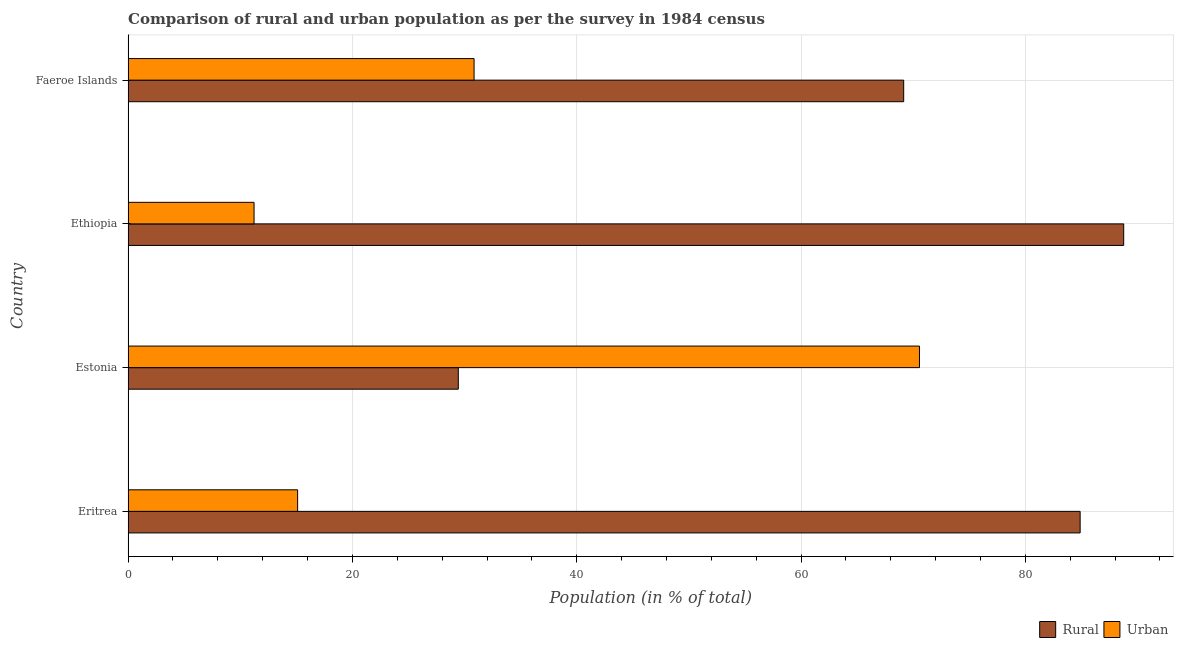How many groups of bars are there?
Your answer should be compact. 4. Are the number of bars per tick equal to the number of legend labels?
Your answer should be compact. Yes. Are the number of bars on each tick of the Y-axis equal?
Provide a short and direct response. Yes. How many bars are there on the 2nd tick from the top?
Your response must be concise. 2. What is the label of the 1st group of bars from the top?
Provide a succinct answer. Faeroe Islands. What is the urban population in Ethiopia?
Keep it short and to the point. 11.23. Across all countries, what is the maximum rural population?
Make the answer very short. 88.77. Across all countries, what is the minimum rural population?
Your answer should be very brief. 29.44. In which country was the rural population maximum?
Make the answer very short. Ethiopia. In which country was the rural population minimum?
Your response must be concise. Estonia. What is the total urban population in the graph?
Your response must be concise. 127.76. What is the difference between the rural population in Estonia and that in Ethiopia?
Provide a succinct answer. -59.33. What is the difference between the rural population in Estonia and the urban population in Ethiopia?
Your response must be concise. 18.21. What is the average rural population per country?
Keep it short and to the point. 68.06. What is the difference between the rural population and urban population in Ethiopia?
Provide a succinct answer. 77.54. In how many countries, is the rural population greater than 88 %?
Keep it short and to the point. 1. What is the ratio of the urban population in Estonia to that in Ethiopia?
Ensure brevity in your answer.  6.28. Is the urban population in Eritrea less than that in Estonia?
Keep it short and to the point. Yes. Is the difference between the rural population in Eritrea and Estonia greater than the difference between the urban population in Eritrea and Estonia?
Keep it short and to the point. Yes. What is the difference between the highest and the second highest urban population?
Offer a terse response. 39.71. What is the difference between the highest and the lowest urban population?
Offer a terse response. 59.33. Is the sum of the urban population in Estonia and Ethiopia greater than the maximum rural population across all countries?
Provide a succinct answer. No. What does the 1st bar from the top in Eritrea represents?
Your answer should be very brief. Urban. What does the 2nd bar from the bottom in Ethiopia represents?
Your answer should be compact. Urban. Are the values on the major ticks of X-axis written in scientific E-notation?
Offer a terse response. No. Does the graph contain any zero values?
Your answer should be very brief. No. Does the graph contain grids?
Your answer should be very brief. Yes. How many legend labels are there?
Offer a very short reply. 2. What is the title of the graph?
Your answer should be compact. Comparison of rural and urban population as per the survey in 1984 census. Does "Urban" appear as one of the legend labels in the graph?
Keep it short and to the point. Yes. What is the label or title of the X-axis?
Your response must be concise. Population (in % of total). What is the Population (in % of total) of Rural in Eritrea?
Your answer should be compact. 84.88. What is the Population (in % of total) in Urban in Eritrea?
Make the answer very short. 15.12. What is the Population (in % of total) in Rural in Estonia?
Offer a very short reply. 29.44. What is the Population (in % of total) of Urban in Estonia?
Your answer should be compact. 70.56. What is the Population (in % of total) of Rural in Ethiopia?
Ensure brevity in your answer.  88.77. What is the Population (in % of total) in Urban in Ethiopia?
Your answer should be compact. 11.23. What is the Population (in % of total) of Rural in Faeroe Islands?
Provide a succinct answer. 69.15. What is the Population (in % of total) of Urban in Faeroe Islands?
Provide a short and direct response. 30.85. Across all countries, what is the maximum Population (in % of total) of Rural?
Give a very brief answer. 88.77. Across all countries, what is the maximum Population (in % of total) of Urban?
Provide a short and direct response. 70.56. Across all countries, what is the minimum Population (in % of total) in Rural?
Your answer should be compact. 29.44. Across all countries, what is the minimum Population (in % of total) in Urban?
Your answer should be very brief. 11.23. What is the total Population (in % of total) in Rural in the graph?
Give a very brief answer. 272.25. What is the total Population (in % of total) of Urban in the graph?
Your response must be concise. 127.75. What is the difference between the Population (in % of total) in Rural in Eritrea and that in Estonia?
Make the answer very short. 55.44. What is the difference between the Population (in % of total) in Urban in Eritrea and that in Estonia?
Make the answer very short. -55.44. What is the difference between the Population (in % of total) in Rural in Eritrea and that in Ethiopia?
Provide a succinct answer. -3.88. What is the difference between the Population (in % of total) of Urban in Eritrea and that in Ethiopia?
Your response must be concise. 3.88. What is the difference between the Population (in % of total) of Rural in Eritrea and that in Faeroe Islands?
Your answer should be very brief. 15.73. What is the difference between the Population (in % of total) in Urban in Eritrea and that in Faeroe Islands?
Make the answer very short. -15.73. What is the difference between the Population (in % of total) in Rural in Estonia and that in Ethiopia?
Keep it short and to the point. -59.33. What is the difference between the Population (in % of total) of Urban in Estonia and that in Ethiopia?
Give a very brief answer. 59.33. What is the difference between the Population (in % of total) of Rural in Estonia and that in Faeroe Islands?
Offer a very short reply. -39.71. What is the difference between the Population (in % of total) of Urban in Estonia and that in Faeroe Islands?
Offer a very short reply. 39.71. What is the difference between the Population (in % of total) of Rural in Ethiopia and that in Faeroe Islands?
Ensure brevity in your answer.  19.62. What is the difference between the Population (in % of total) in Urban in Ethiopia and that in Faeroe Islands?
Provide a short and direct response. -19.62. What is the difference between the Population (in % of total) in Rural in Eritrea and the Population (in % of total) in Urban in Estonia?
Make the answer very short. 14.33. What is the difference between the Population (in % of total) in Rural in Eritrea and the Population (in % of total) in Urban in Ethiopia?
Your answer should be compact. 73.65. What is the difference between the Population (in % of total) in Rural in Eritrea and the Population (in % of total) in Urban in Faeroe Islands?
Offer a terse response. 54.03. What is the difference between the Population (in % of total) of Rural in Estonia and the Population (in % of total) of Urban in Ethiopia?
Offer a terse response. 18.21. What is the difference between the Population (in % of total) in Rural in Estonia and the Population (in % of total) in Urban in Faeroe Islands?
Offer a very short reply. -1.41. What is the difference between the Population (in % of total) of Rural in Ethiopia and the Population (in % of total) of Urban in Faeroe Islands?
Your answer should be very brief. 57.92. What is the average Population (in % of total) in Rural per country?
Your answer should be compact. 68.06. What is the average Population (in % of total) in Urban per country?
Provide a succinct answer. 31.94. What is the difference between the Population (in % of total) of Rural and Population (in % of total) of Urban in Eritrea?
Provide a short and direct response. 69.77. What is the difference between the Population (in % of total) of Rural and Population (in % of total) of Urban in Estonia?
Offer a terse response. -41.12. What is the difference between the Population (in % of total) of Rural and Population (in % of total) of Urban in Ethiopia?
Your answer should be very brief. 77.54. What is the difference between the Population (in % of total) of Rural and Population (in % of total) of Urban in Faeroe Islands?
Make the answer very short. 38.3. What is the ratio of the Population (in % of total) in Rural in Eritrea to that in Estonia?
Offer a terse response. 2.88. What is the ratio of the Population (in % of total) of Urban in Eritrea to that in Estonia?
Offer a very short reply. 0.21. What is the ratio of the Population (in % of total) of Rural in Eritrea to that in Ethiopia?
Your answer should be very brief. 0.96. What is the ratio of the Population (in % of total) in Urban in Eritrea to that in Ethiopia?
Provide a short and direct response. 1.35. What is the ratio of the Population (in % of total) in Rural in Eritrea to that in Faeroe Islands?
Your answer should be compact. 1.23. What is the ratio of the Population (in % of total) of Urban in Eritrea to that in Faeroe Islands?
Provide a short and direct response. 0.49. What is the ratio of the Population (in % of total) of Rural in Estonia to that in Ethiopia?
Make the answer very short. 0.33. What is the ratio of the Population (in % of total) of Urban in Estonia to that in Ethiopia?
Provide a succinct answer. 6.28. What is the ratio of the Population (in % of total) of Rural in Estonia to that in Faeroe Islands?
Provide a short and direct response. 0.43. What is the ratio of the Population (in % of total) of Urban in Estonia to that in Faeroe Islands?
Offer a terse response. 2.29. What is the ratio of the Population (in % of total) in Rural in Ethiopia to that in Faeroe Islands?
Offer a terse response. 1.28. What is the ratio of the Population (in % of total) of Urban in Ethiopia to that in Faeroe Islands?
Give a very brief answer. 0.36. What is the difference between the highest and the second highest Population (in % of total) of Rural?
Your answer should be very brief. 3.88. What is the difference between the highest and the second highest Population (in % of total) of Urban?
Offer a terse response. 39.71. What is the difference between the highest and the lowest Population (in % of total) in Rural?
Offer a very short reply. 59.33. What is the difference between the highest and the lowest Population (in % of total) of Urban?
Your answer should be compact. 59.33. 